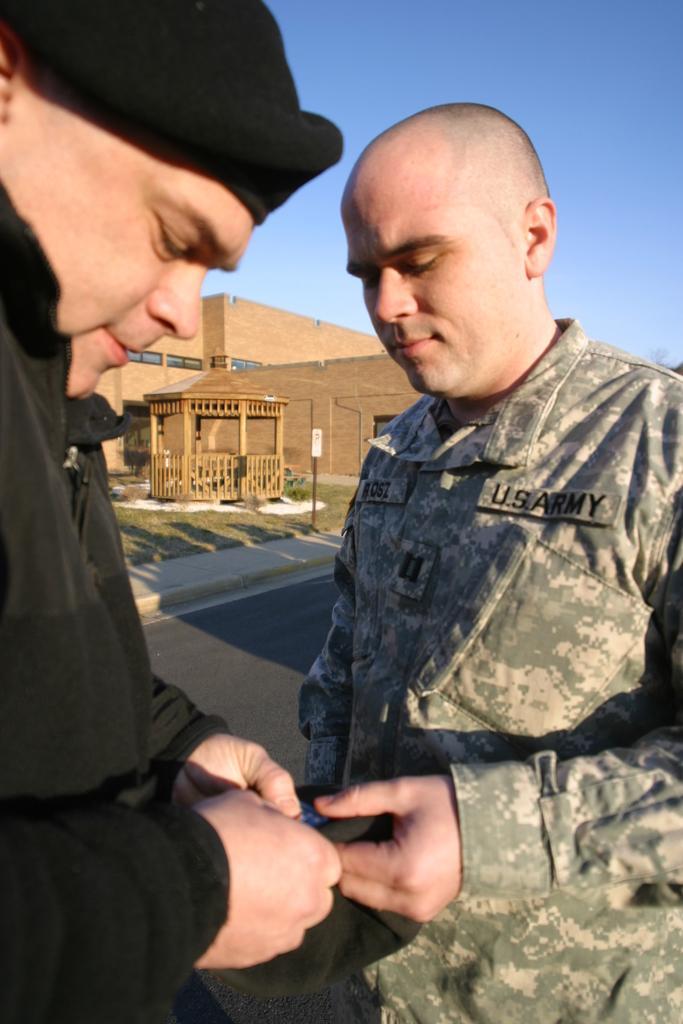Please provide a concise description of this image. In front of the picture, we see two men are standing. They are holding an object in their hands. The man on the right side is in the uniform. At the bottom, we see the road. In the middle, we see a gazebo, a pole and the grass. There are trees in the background. At the top, we see the sky. 